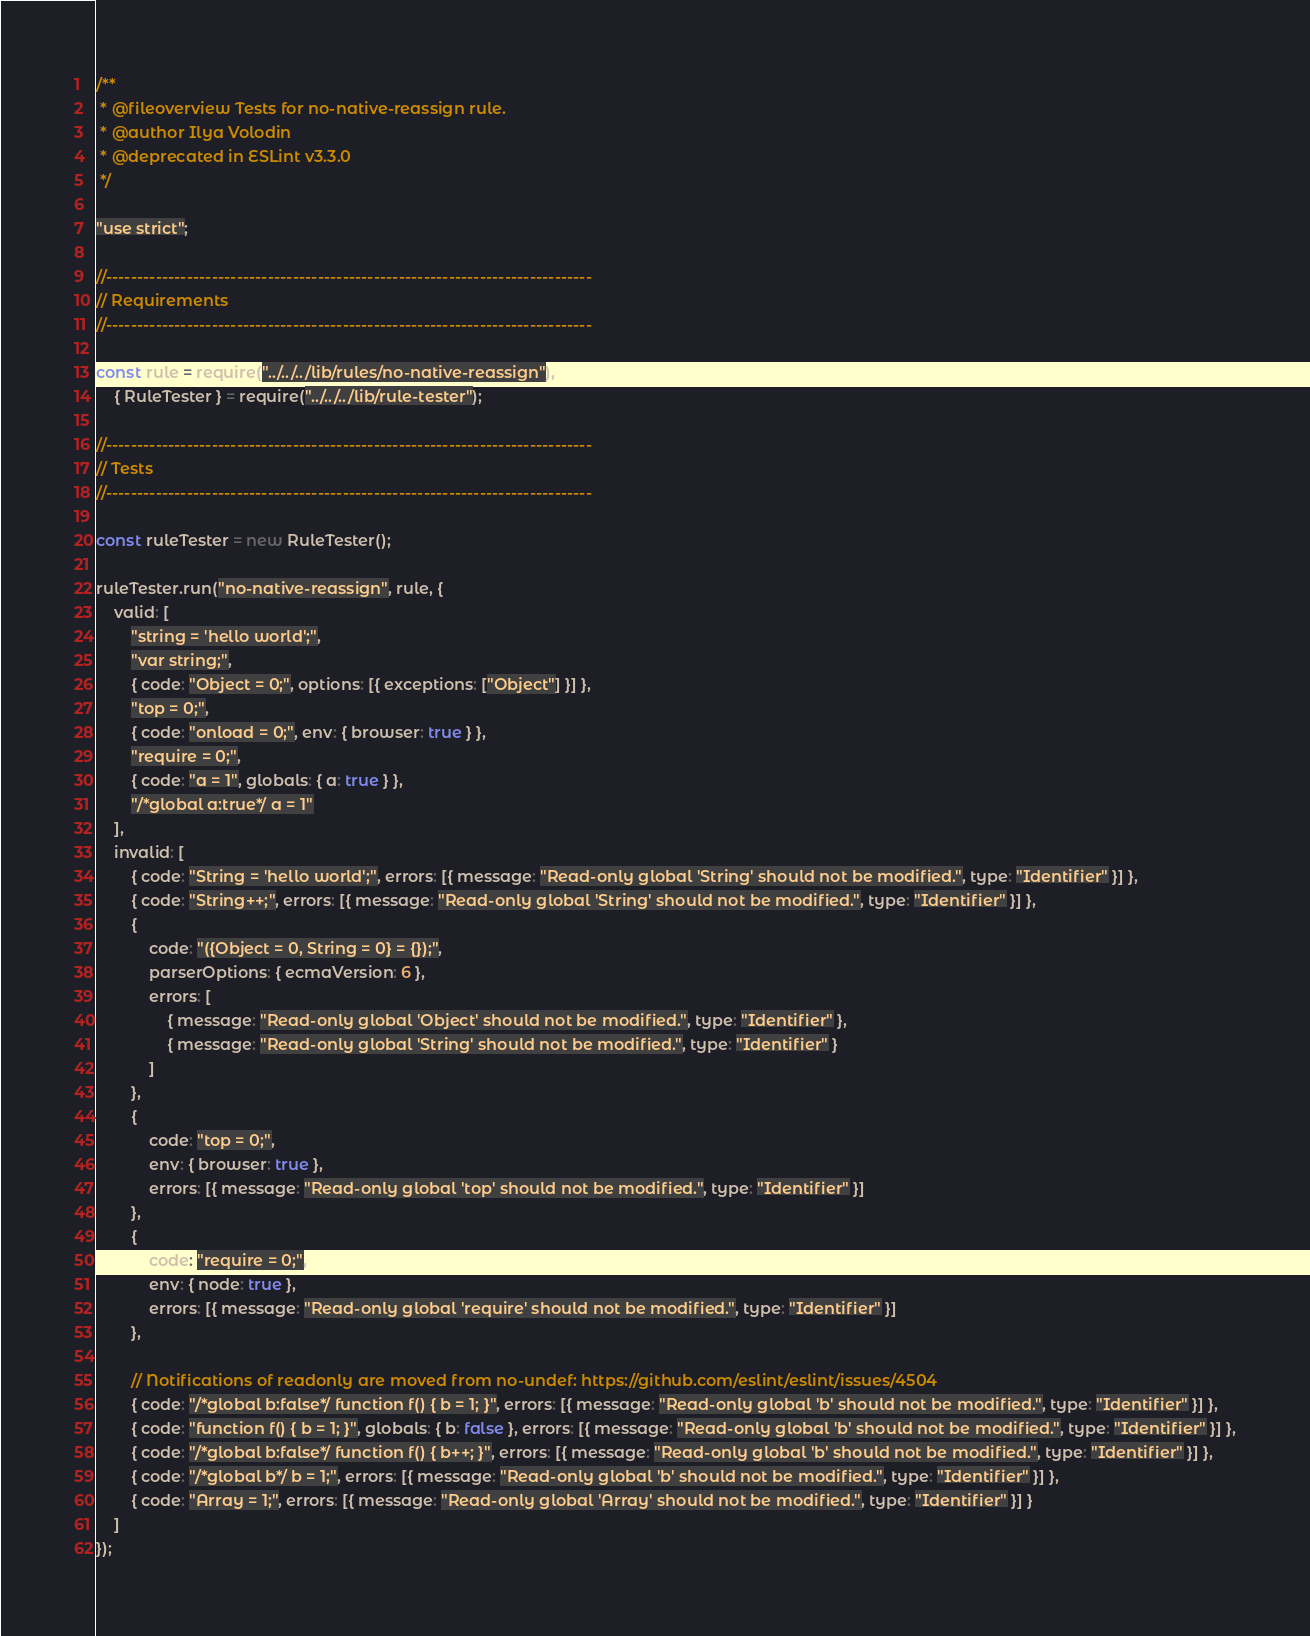Convert code to text. <code><loc_0><loc_0><loc_500><loc_500><_JavaScript_>/**
 * @fileoverview Tests for no-native-reassign rule.
 * @author Ilya Volodin
 * @deprecated in ESLint v3.3.0
 */

"use strict";

//------------------------------------------------------------------------------
// Requirements
//------------------------------------------------------------------------------

const rule = require("../../../lib/rules/no-native-reassign"),
    { RuleTester } = require("../../../lib/rule-tester");

//------------------------------------------------------------------------------
// Tests
//------------------------------------------------------------------------------

const ruleTester = new RuleTester();

ruleTester.run("no-native-reassign", rule, {
    valid: [
        "string = 'hello world';",
        "var string;",
        { code: "Object = 0;", options: [{ exceptions: ["Object"] }] },
        "top = 0;",
        { code: "onload = 0;", env: { browser: true } },
        "require = 0;",
        { code: "a = 1", globals: { a: true } },
        "/*global a:true*/ a = 1"
    ],
    invalid: [
        { code: "String = 'hello world';", errors: [{ message: "Read-only global 'String' should not be modified.", type: "Identifier" }] },
        { code: "String++;", errors: [{ message: "Read-only global 'String' should not be modified.", type: "Identifier" }] },
        {
            code: "({Object = 0, String = 0} = {});",
            parserOptions: { ecmaVersion: 6 },
            errors: [
                { message: "Read-only global 'Object' should not be modified.", type: "Identifier" },
                { message: "Read-only global 'String' should not be modified.", type: "Identifier" }
            ]
        },
        {
            code: "top = 0;",
            env: { browser: true },
            errors: [{ message: "Read-only global 'top' should not be modified.", type: "Identifier" }]
        },
        {
            code: "require = 0;",
            env: { node: true },
            errors: [{ message: "Read-only global 'require' should not be modified.", type: "Identifier" }]
        },

        // Notifications of readonly are moved from no-undef: https://github.com/eslint/eslint/issues/4504
        { code: "/*global b:false*/ function f() { b = 1; }", errors: [{ message: "Read-only global 'b' should not be modified.", type: "Identifier" }] },
        { code: "function f() { b = 1; }", globals: { b: false }, errors: [{ message: "Read-only global 'b' should not be modified.", type: "Identifier" }] },
        { code: "/*global b:false*/ function f() { b++; }", errors: [{ message: "Read-only global 'b' should not be modified.", type: "Identifier" }] },
        { code: "/*global b*/ b = 1;", errors: [{ message: "Read-only global 'b' should not be modified.", type: "Identifier" }] },
        { code: "Array = 1;", errors: [{ message: "Read-only global 'Array' should not be modified.", type: "Identifier" }] }
    ]
});
</code> 